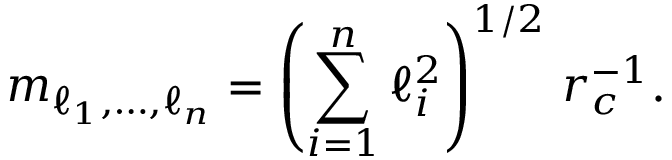Convert formula to latex. <formula><loc_0><loc_0><loc_500><loc_500>m _ { \ell _ { 1 } , \dots , \ell _ { n } } = \left ( \sum _ { i = 1 } ^ { n } \ell _ { i } ^ { 2 } \right ) ^ { 1 / 2 } \, r _ { c } ^ { - 1 } .</formula> 